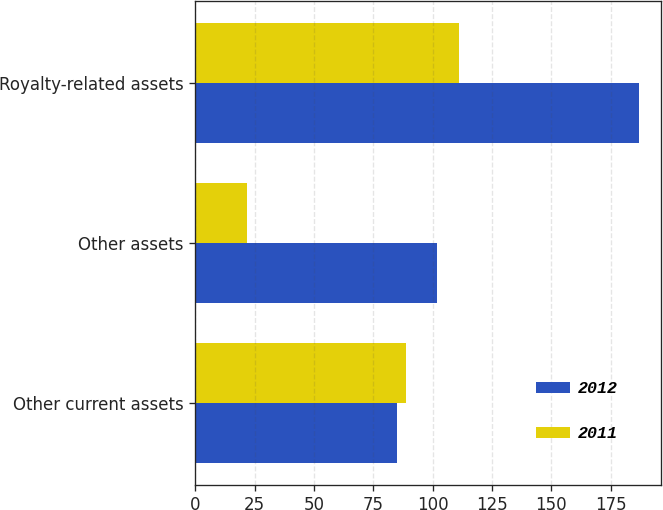<chart> <loc_0><loc_0><loc_500><loc_500><stacked_bar_chart><ecel><fcel>Other current assets<fcel>Other assets<fcel>Royalty-related assets<nl><fcel>2012<fcel>85<fcel>102<fcel>187<nl><fcel>2011<fcel>89<fcel>22<fcel>111<nl></chart> 